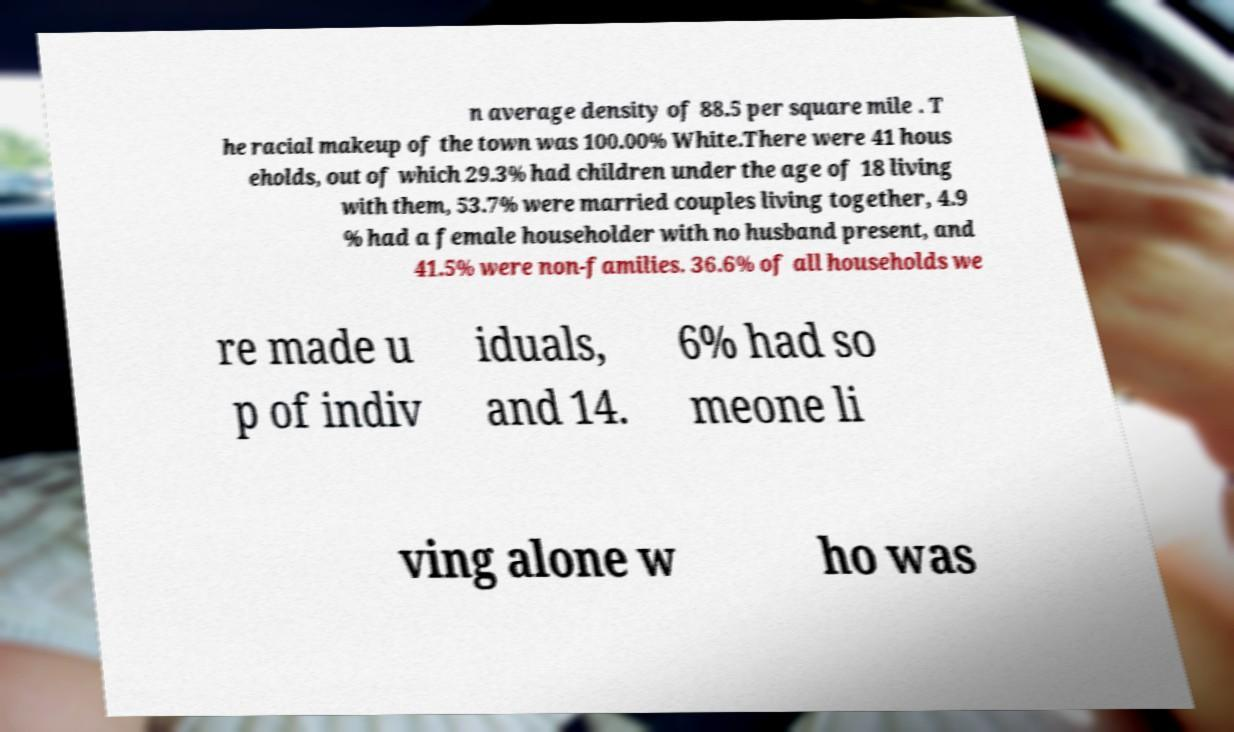Please read and relay the text visible in this image. What does it say? n average density of 88.5 per square mile . T he racial makeup of the town was 100.00% White.There were 41 hous eholds, out of which 29.3% had children under the age of 18 living with them, 53.7% were married couples living together, 4.9 % had a female householder with no husband present, and 41.5% were non-families. 36.6% of all households we re made u p of indiv iduals, and 14. 6% had so meone li ving alone w ho was 